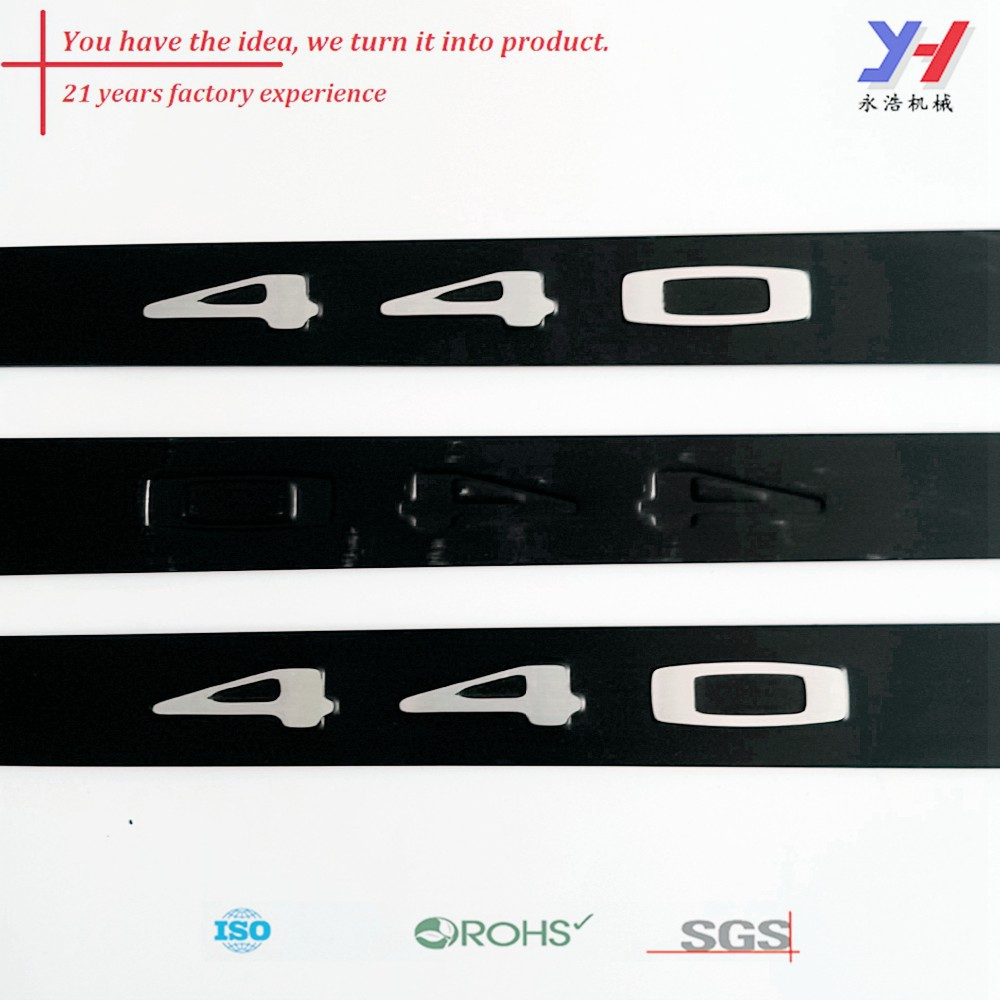If this image were part of an adventure story, where would the numbers '40' be leading the protagonists? In an adventure story, the numbers '40' might be part of an ancient, cryptic code leading the protagonists to a legendary artifact hidden for centuries. This artifact, known as 'The Mark of 40,' is believed to grant unparalleled wisdom and power. The journey to find this artifact would be fraught with challenges, from decoding clues embedded in historic relics to overcoming natural obstacles and rival seekers. Along the way, the '40' will reveal itself in mysterious symbols and patterns, guiding the heroes to their ultimate destination and unlocking secrets that change their world forever. 